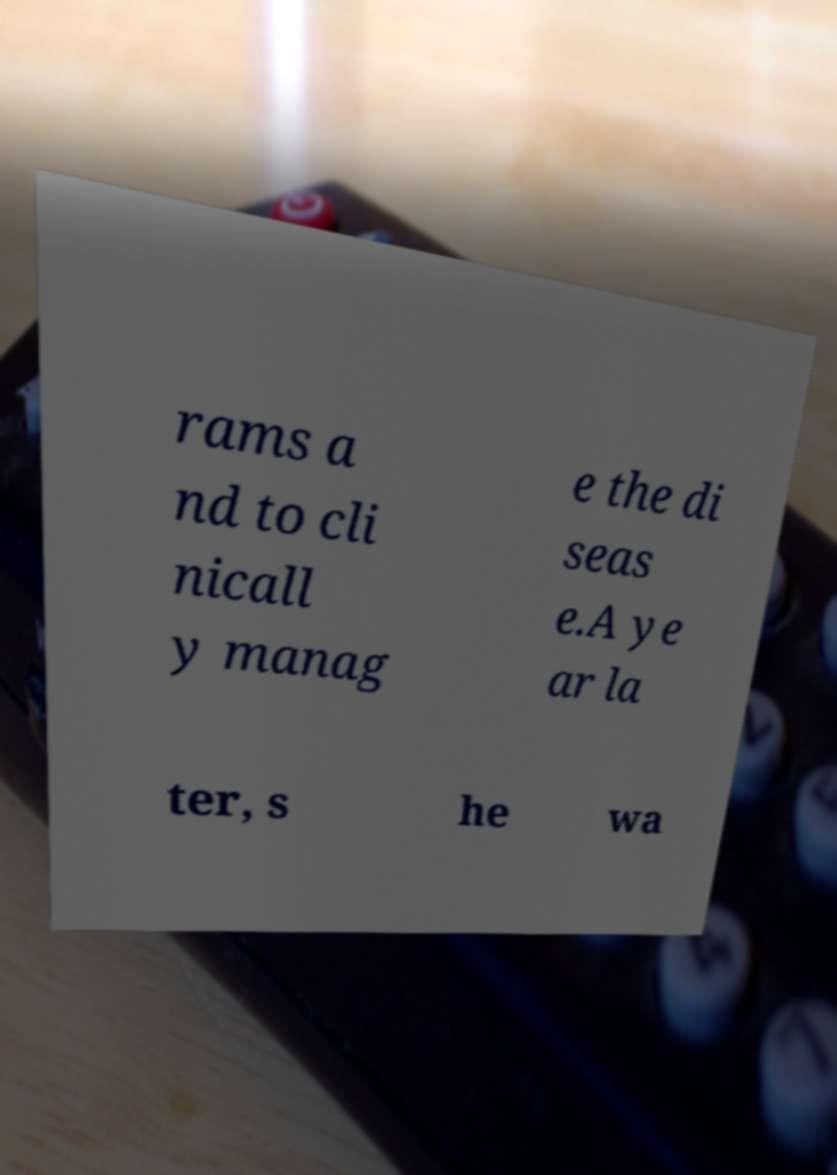Can you accurately transcribe the text from the provided image for me? rams a nd to cli nicall y manag e the di seas e.A ye ar la ter, s he wa 